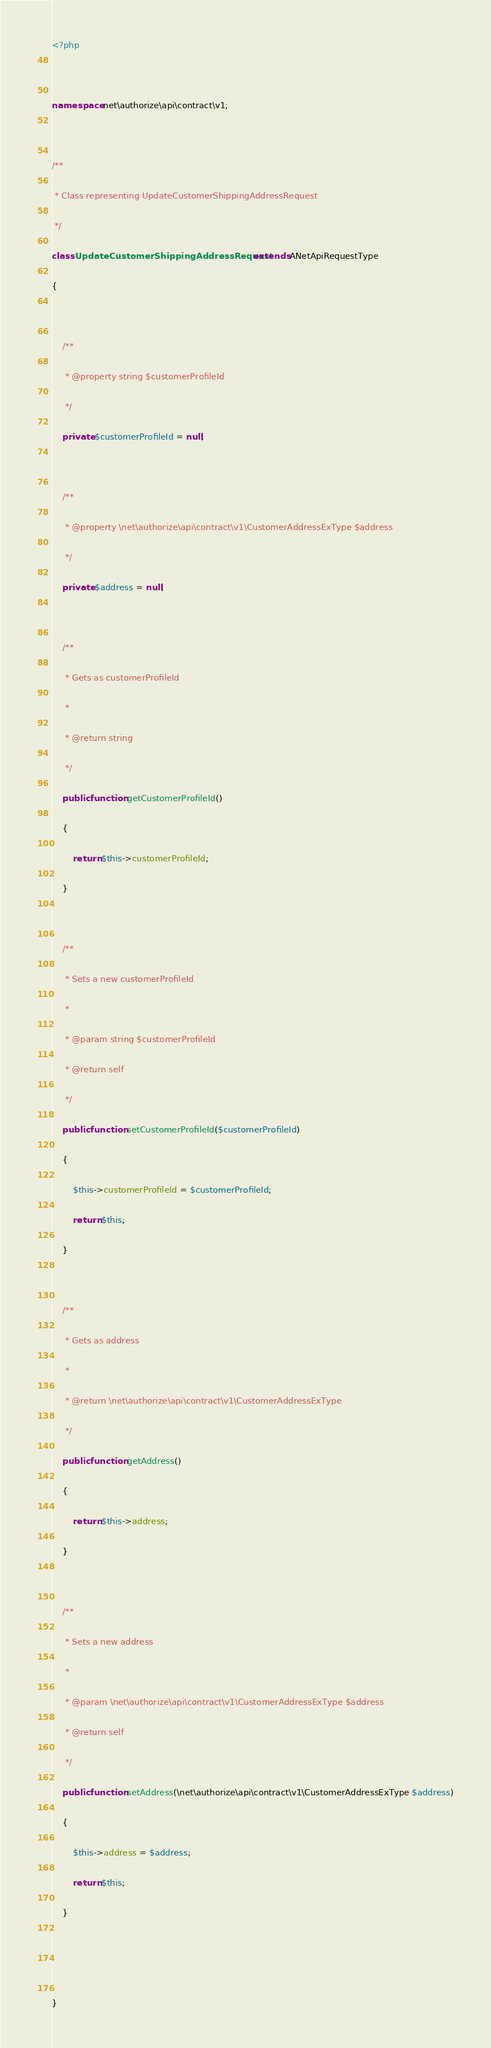Convert code to text. <code><loc_0><loc_0><loc_500><loc_500><_PHP_><?php

namespace net\authorize\api\contract\v1;

/**
 * Class representing UpdateCustomerShippingAddressRequest
 */
class UpdateCustomerShippingAddressRequest extends ANetApiRequestType
{

    /**
     * @property string $customerProfileId
     */
    private $customerProfileId = null;

    /**
     * @property \net\authorize\api\contract\v1\CustomerAddressExType $address
     */
    private $address = null;

    /**
     * Gets as customerProfileId
     *
     * @return string
     */
    public function getCustomerProfileId()
    {
        return $this->customerProfileId;
    }

    /**
     * Sets a new customerProfileId
     *
     * @param string $customerProfileId
     * @return self
     */
    public function setCustomerProfileId($customerProfileId)
    {
        $this->customerProfileId = $customerProfileId;
        return $this;
    }

    /**
     * Gets as address
     *
     * @return \net\authorize\api\contract\v1\CustomerAddressExType
     */
    public function getAddress()
    {
        return $this->address;
    }

    /**
     * Sets a new address
     *
     * @param \net\authorize\api\contract\v1\CustomerAddressExType $address
     * @return self
     */
    public function setAddress(\net\authorize\api\contract\v1\CustomerAddressExType $address)
    {
        $this->address = $address;
        return $this;
    }


}

</code> 